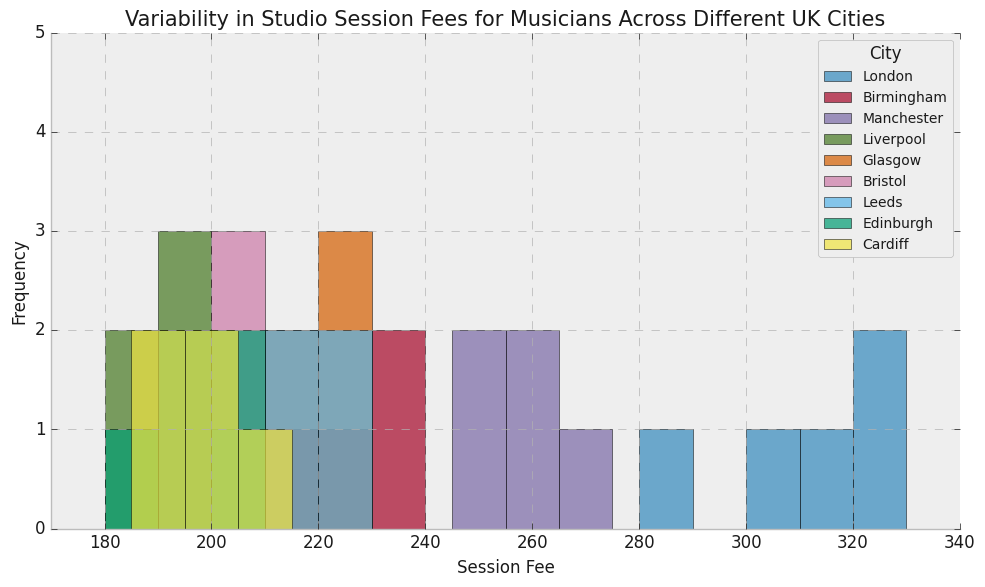What city has the highest session fees? To determine the highest session fees, observe the histogram data for each city. London shows the highest session fees, with fees going up to 330.
Answer: London Which city has the lowest session fees? Look at the histogram data for the lowest session fee across cities. Liverpool's session fees drop as low as 180, which is the minimum.
Answer: Liverpool What is the range of session fees in Manchester? The range is calculated by finding the difference between the maximum and minimum session fees. In Manchester, the fees range from 245 to 270. So, 270 - 245 = 25.
Answer: 25 Which city has the most uniform distribution of session fees within the observed range? By examining the spread and frequency of the bars in the histograms, Glasgow shows relatively uniform distribution across its session fee range from 210 to 230 compared to other cities which have more variability.
Answer: Glasgow How many cities have session fees overlapping in the range between 200 and 210? Check the histograms for counts between 200 and 210. The cities are Birmingham, Liverpool, Bristol, Leeds, Edinburgh, and Cardiff (a total of 6).
Answer: 6 If you were a musician looking for moderately-priced session fees (say, around 200), which city or cities would you consider? Search for cities where histograms show a high frequency for session fees around 200. The cities that meet this criterion are Birmingham, Liverpool, Bristol, Leeds, Edinburgh, and Cardiff.
Answer: Birmingham, Liverpool, Bristol, Leeds, Edinburgh, Cardiff Compare the session fee ranges of Bristol and Cardiff. Which city has a wider range? Look at both cities' fee ranges: Bristol ranges from 190 to 210 (20 units), while Cardiff ranges from 185 to 210 (25 units). So, Cardiff has a wider range.
Answer: Cardiff Which city has distinct peaks at higher session fee values? The peaks in the histogram for London show session fees around 310 and higher, making them distinct compared to other cities.
Answer: London What session fee is most common in Birmingham? Check the histogram for Birmingham to see the highest bar. The session fee of 220 has the highest frequency.
Answer: 220 